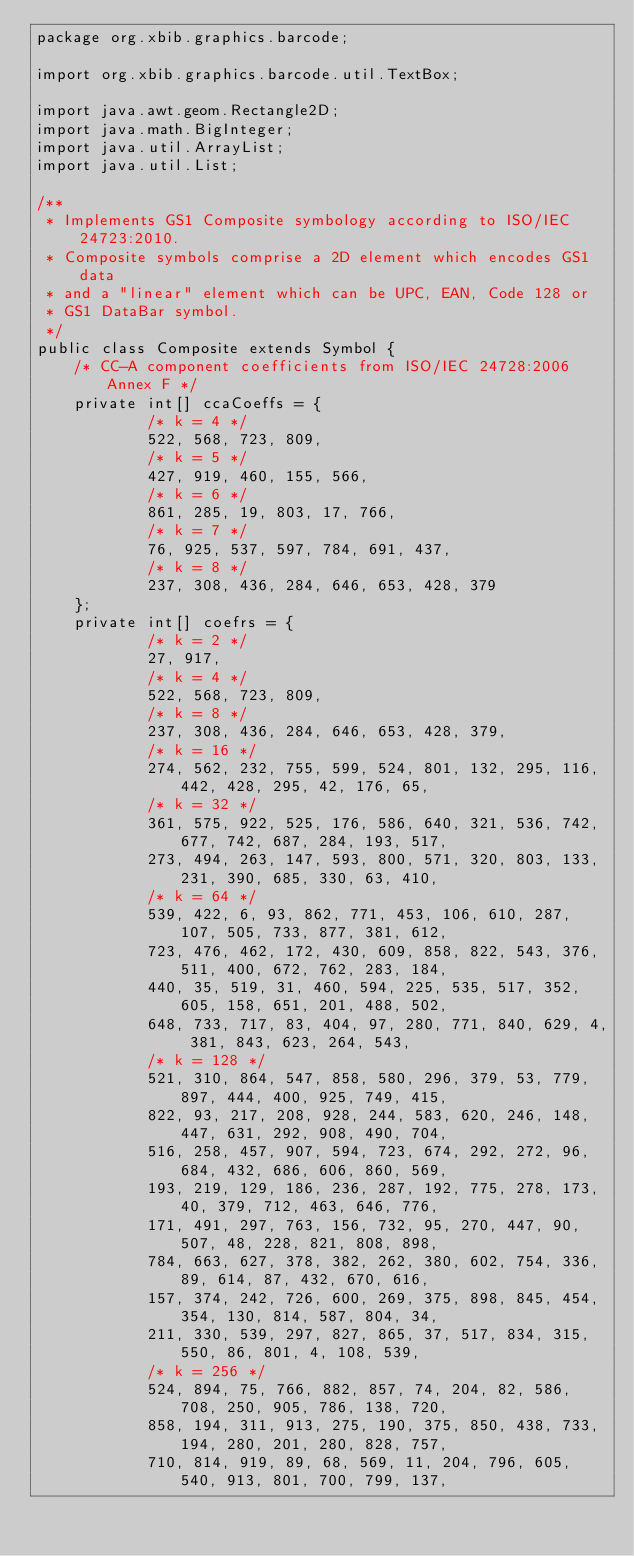Convert code to text. <code><loc_0><loc_0><loc_500><loc_500><_Java_>package org.xbib.graphics.barcode;

import org.xbib.graphics.barcode.util.TextBox;

import java.awt.geom.Rectangle2D;
import java.math.BigInteger;
import java.util.ArrayList;
import java.util.List;

/**
 * Implements GS1 Composite symbology according to ISO/IEC 24723:2010.
 * Composite symbols comprise a 2D element which encodes GS1 data
 * and a "linear" element which can be UPC, EAN, Code 128 or
 * GS1 DataBar symbol.
 */
public class Composite extends Symbol {
    /* CC-A component coefficients from ISO/IEC 24728:2006 Annex F */
    private int[] ccaCoeffs = {
            /* k = 4 */
            522, 568, 723, 809,
            /* k = 5 */
            427, 919, 460, 155, 566,
            /* k = 6 */
            861, 285, 19, 803, 17, 766,
            /* k = 7 */
            76, 925, 537, 597, 784, 691, 437,
            /* k = 8 */
            237, 308, 436, 284, 646, 653, 428, 379
    };
    private int[] coefrs = {
            /* k = 2 */
            27, 917,
            /* k = 4 */
            522, 568, 723, 809,
            /* k = 8 */
            237, 308, 436, 284, 646, 653, 428, 379,
            /* k = 16 */
            274, 562, 232, 755, 599, 524, 801, 132, 295, 116, 442, 428, 295, 42, 176, 65,
            /* k = 32 */
            361, 575, 922, 525, 176, 586, 640, 321, 536, 742, 677, 742, 687, 284, 193, 517,
            273, 494, 263, 147, 593, 800, 571, 320, 803, 133, 231, 390, 685, 330, 63, 410,
            /* k = 64 */
            539, 422, 6, 93, 862, 771, 453, 106, 610, 287, 107, 505, 733, 877, 381, 612,
            723, 476, 462, 172, 430, 609, 858, 822, 543, 376, 511, 400, 672, 762, 283, 184,
            440, 35, 519, 31, 460, 594, 225, 535, 517, 352, 605, 158, 651, 201, 488, 502,
            648, 733, 717, 83, 404, 97, 280, 771, 840, 629, 4, 381, 843, 623, 264, 543,
            /* k = 128 */
            521, 310, 864, 547, 858, 580, 296, 379, 53, 779, 897, 444, 400, 925, 749, 415,
            822, 93, 217, 208, 928, 244, 583, 620, 246, 148, 447, 631, 292, 908, 490, 704,
            516, 258, 457, 907, 594, 723, 674, 292, 272, 96, 684, 432, 686, 606, 860, 569,
            193, 219, 129, 186, 236, 287, 192, 775, 278, 173, 40, 379, 712, 463, 646, 776,
            171, 491, 297, 763, 156, 732, 95, 270, 447, 90, 507, 48, 228, 821, 808, 898,
            784, 663, 627, 378, 382, 262, 380, 602, 754, 336, 89, 614, 87, 432, 670, 616,
            157, 374, 242, 726, 600, 269, 375, 898, 845, 454, 354, 130, 814, 587, 804, 34,
            211, 330, 539, 297, 827, 865, 37, 517, 834, 315, 550, 86, 801, 4, 108, 539,
            /* k = 256 */
            524, 894, 75, 766, 882, 857, 74, 204, 82, 586, 708, 250, 905, 786, 138, 720,
            858, 194, 311, 913, 275, 190, 375, 850, 438, 733, 194, 280, 201, 280, 828, 757,
            710, 814, 919, 89, 68, 569, 11, 204, 796, 605, 540, 913, 801, 700, 799, 137,</code> 